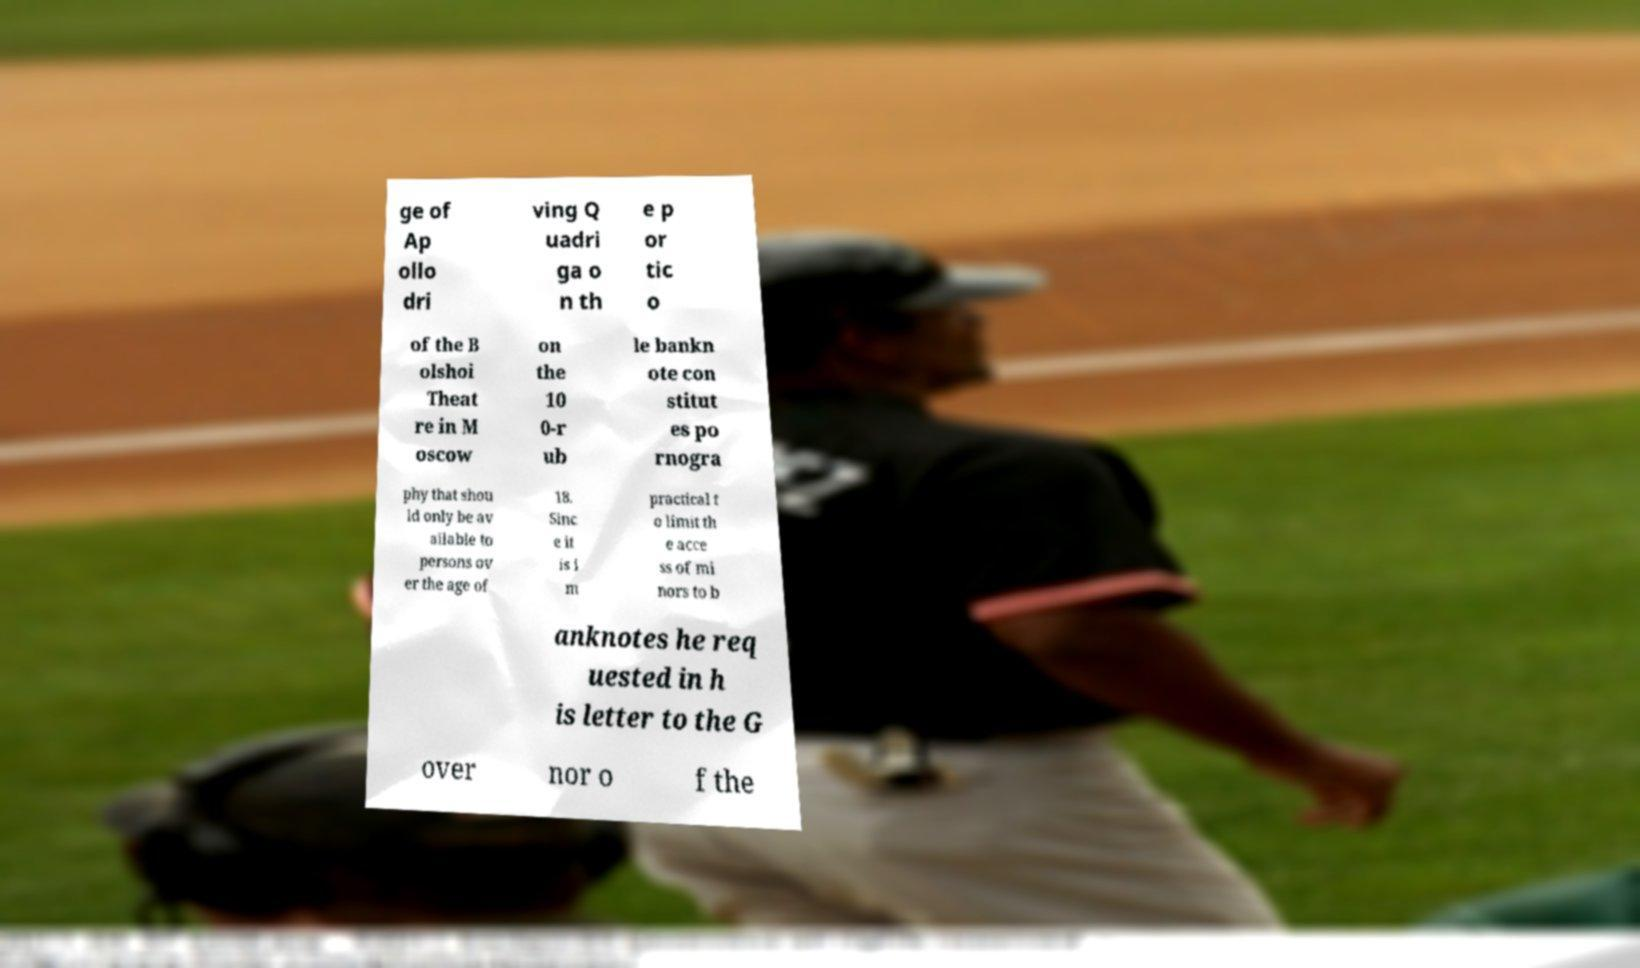For documentation purposes, I need the text within this image transcribed. Could you provide that? ge of Ap ollo dri ving Q uadri ga o n th e p or tic o of the B olshoi Theat re in M oscow on the 10 0-r ub le bankn ote con stitut es po rnogra phy that shou ld only be av ailable to persons ov er the age of 18. Sinc e it is i m practical t o limit th e acce ss of mi nors to b anknotes he req uested in h is letter to the G over nor o f the 